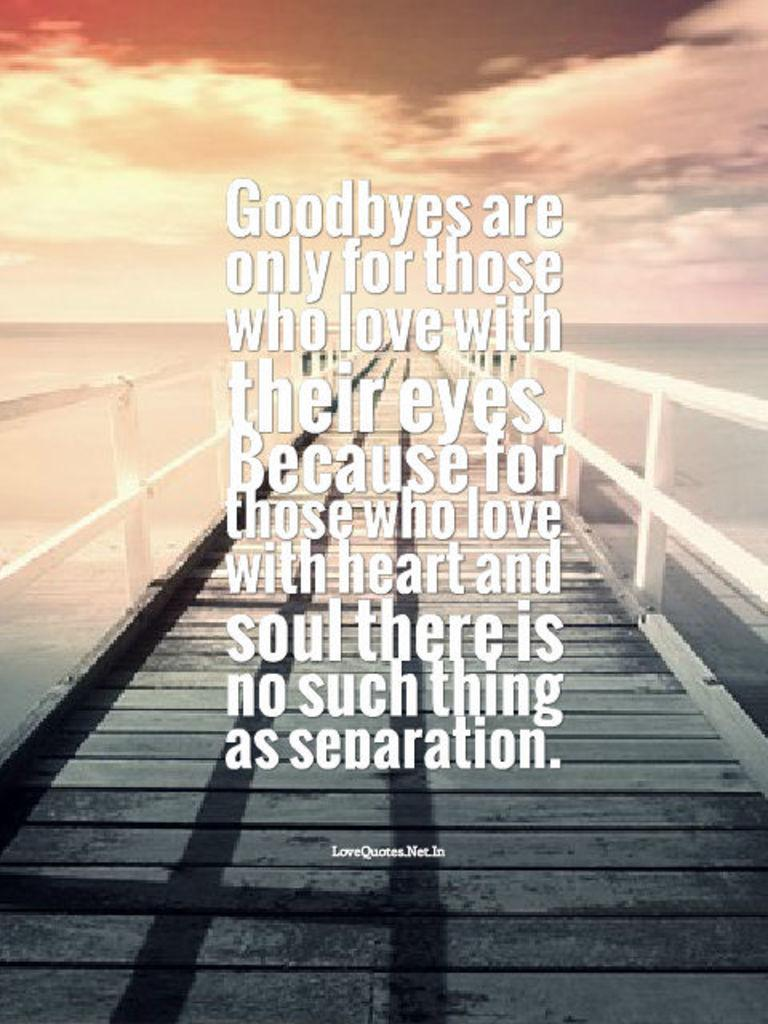Provide a one-sentence caption for the provided image. a pier over looking a sunset with words about Goodbyes over it. 